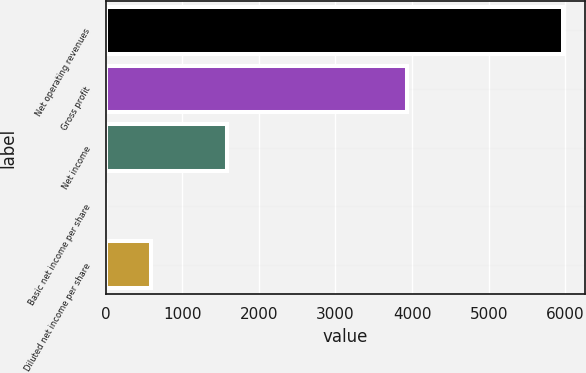<chart> <loc_0><loc_0><loc_500><loc_500><bar_chart><fcel>Net operating revenues<fcel>Gross profit<fcel>Net income<fcel>Basic net income per share<fcel>Diluted net income per share<nl><fcel>5965<fcel>3935<fcel>1584<fcel>0.65<fcel>597.09<nl></chart> 